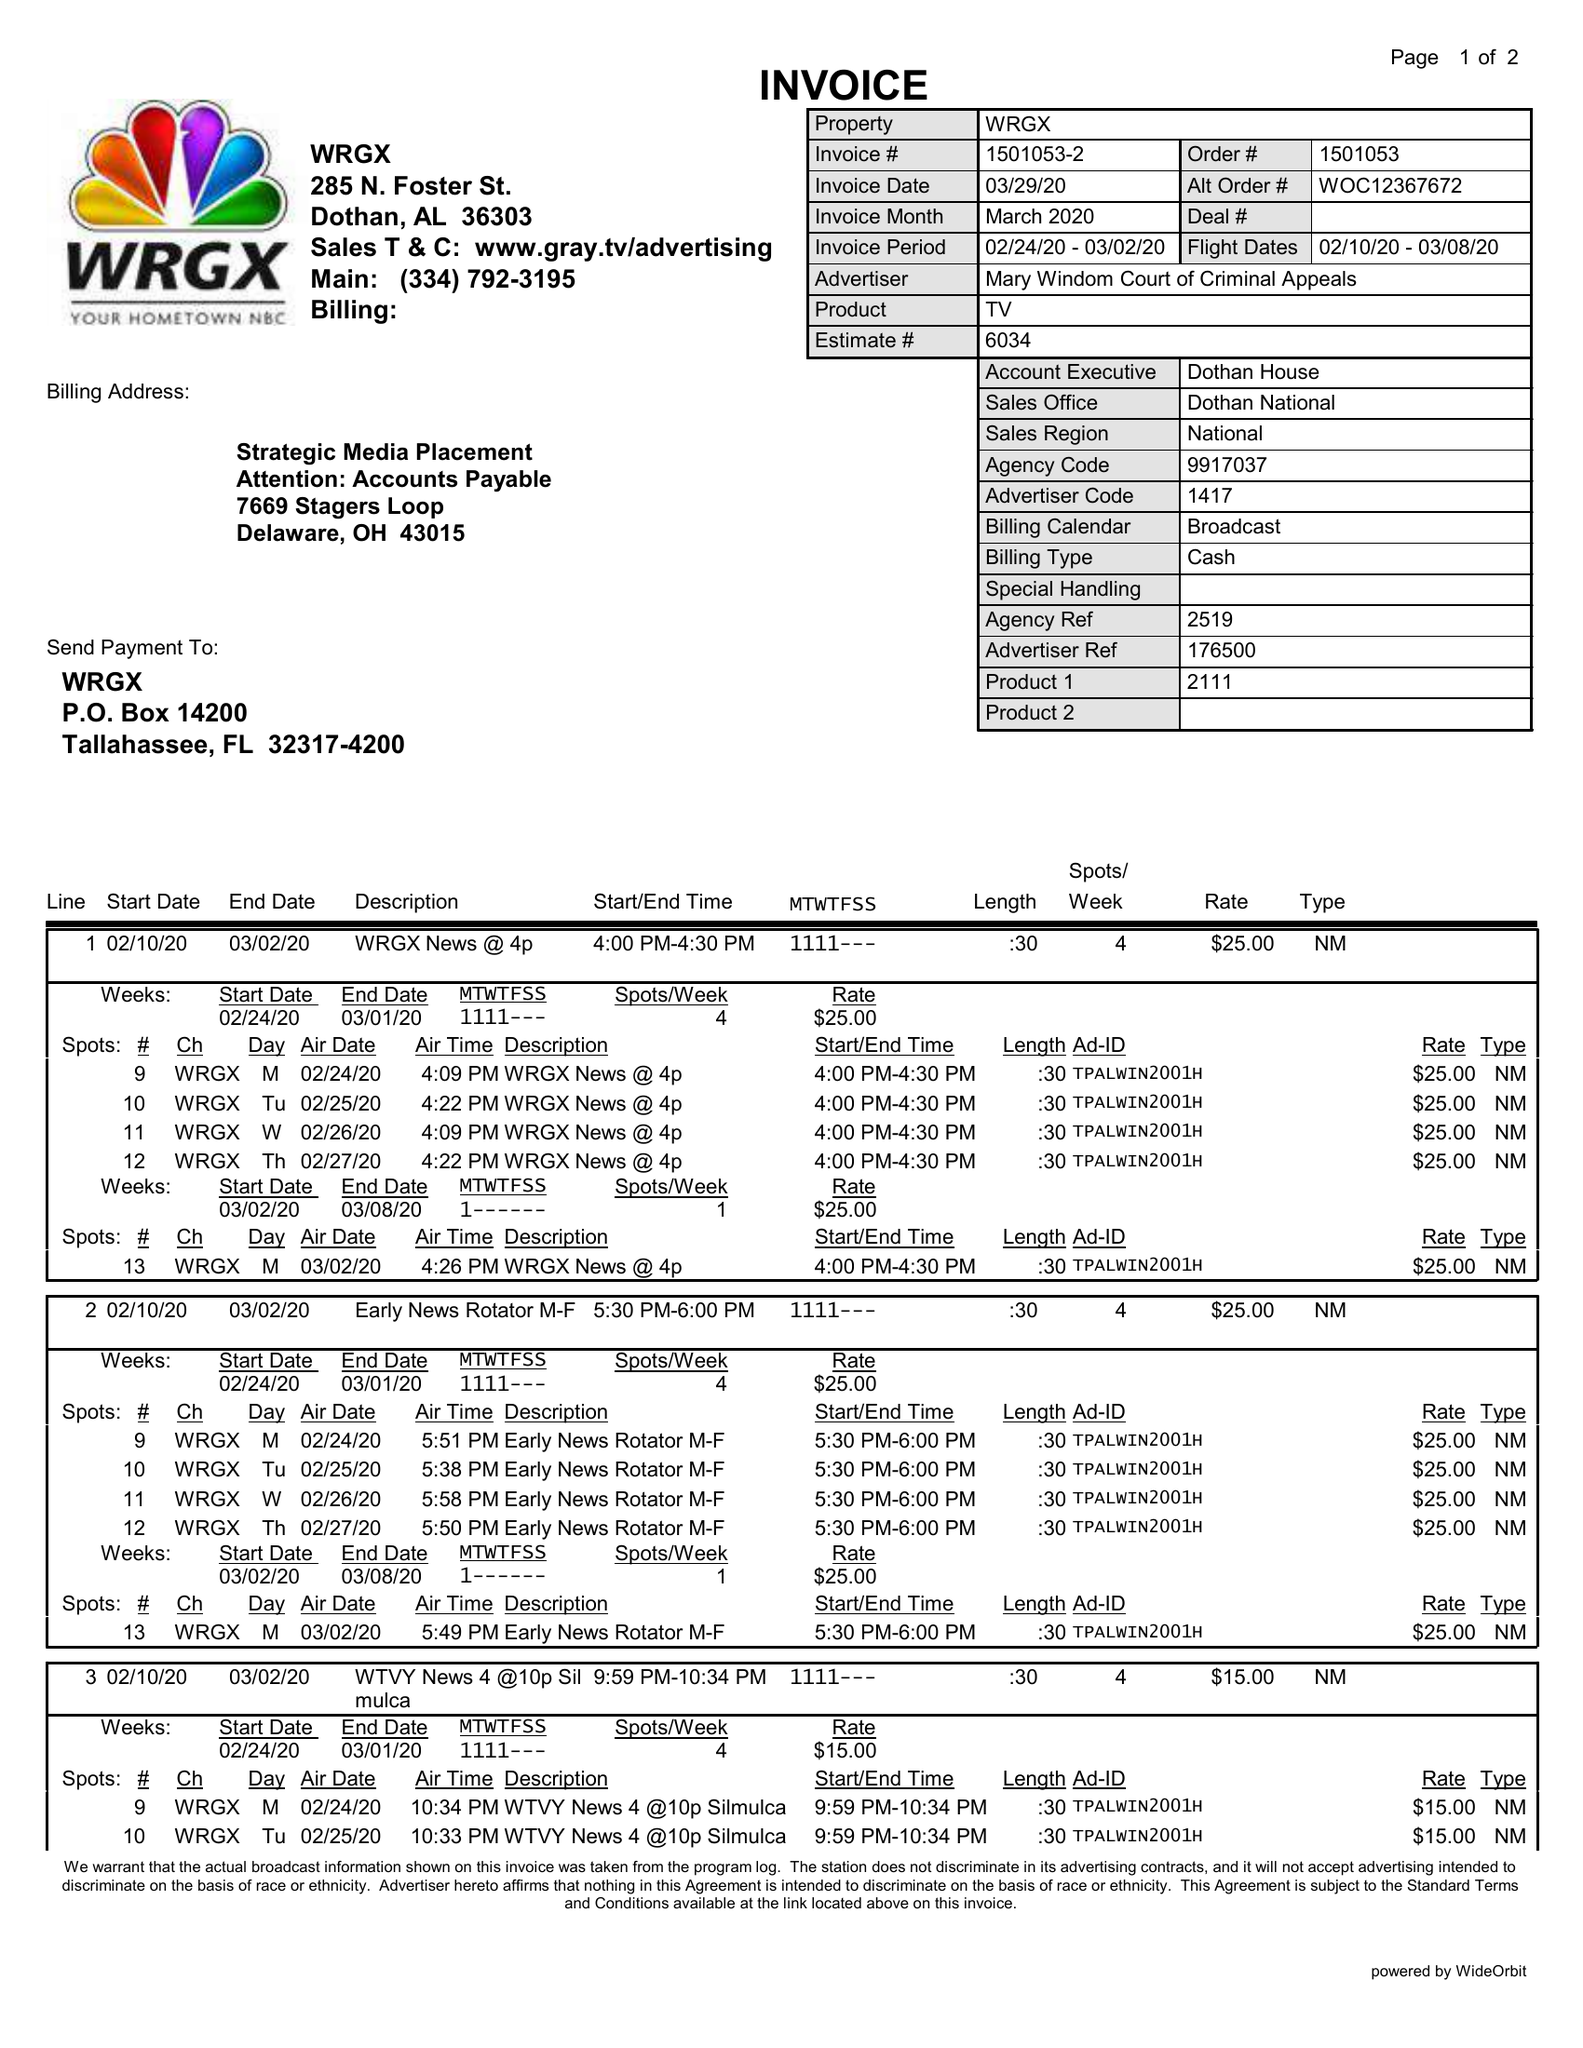What is the value for the flight_from?
Answer the question using a single word or phrase. 02/10/20 